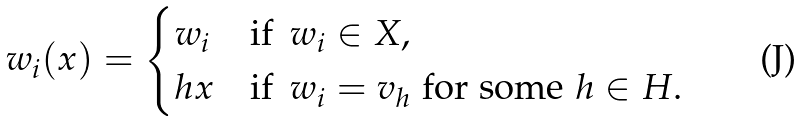Convert formula to latex. <formula><loc_0><loc_0><loc_500><loc_500>w _ { i } ( x ) = \begin{cases} w _ { i } & \text {if } \, w _ { i } \in X , \\ h x & \text {if } \, w _ { i } = v _ { h } \text { for some } h \in H . \end{cases}</formula> 